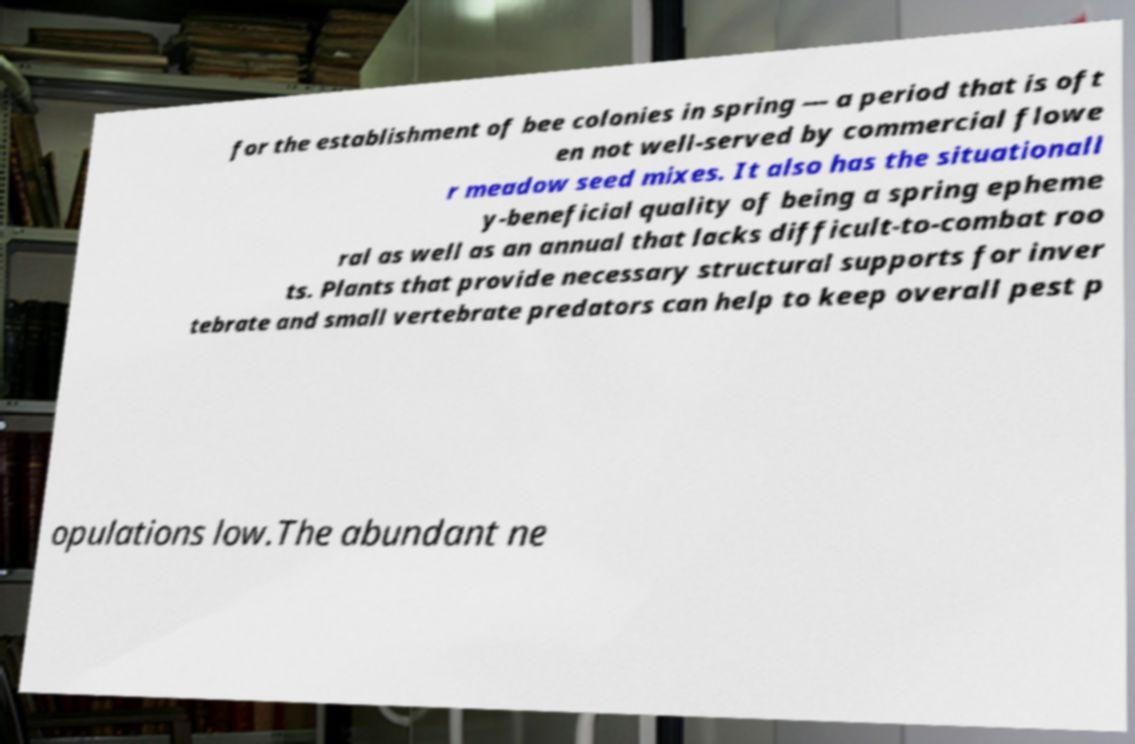What messages or text are displayed in this image? I need them in a readable, typed format. for the establishment of bee colonies in spring — a period that is oft en not well-served by commercial flowe r meadow seed mixes. It also has the situationall y-beneficial quality of being a spring epheme ral as well as an annual that lacks difficult-to-combat roo ts. Plants that provide necessary structural supports for inver tebrate and small vertebrate predators can help to keep overall pest p opulations low.The abundant ne 